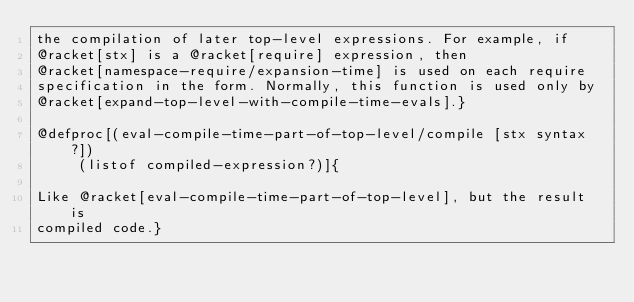<code> <loc_0><loc_0><loc_500><loc_500><_Racket_>the compilation of later top-level expressions. For example, if
@racket[stx] is a @racket[require] expression, then
@racket[namespace-require/expansion-time] is used on each require
specification in the form. Normally, this function is used only by
@racket[expand-top-level-with-compile-time-evals].}

@defproc[(eval-compile-time-part-of-top-level/compile [stx syntax?])
	 (listof compiled-expression?)]{ 

Like @racket[eval-compile-time-part-of-top-level], but the result is
compiled code.}
</code> 